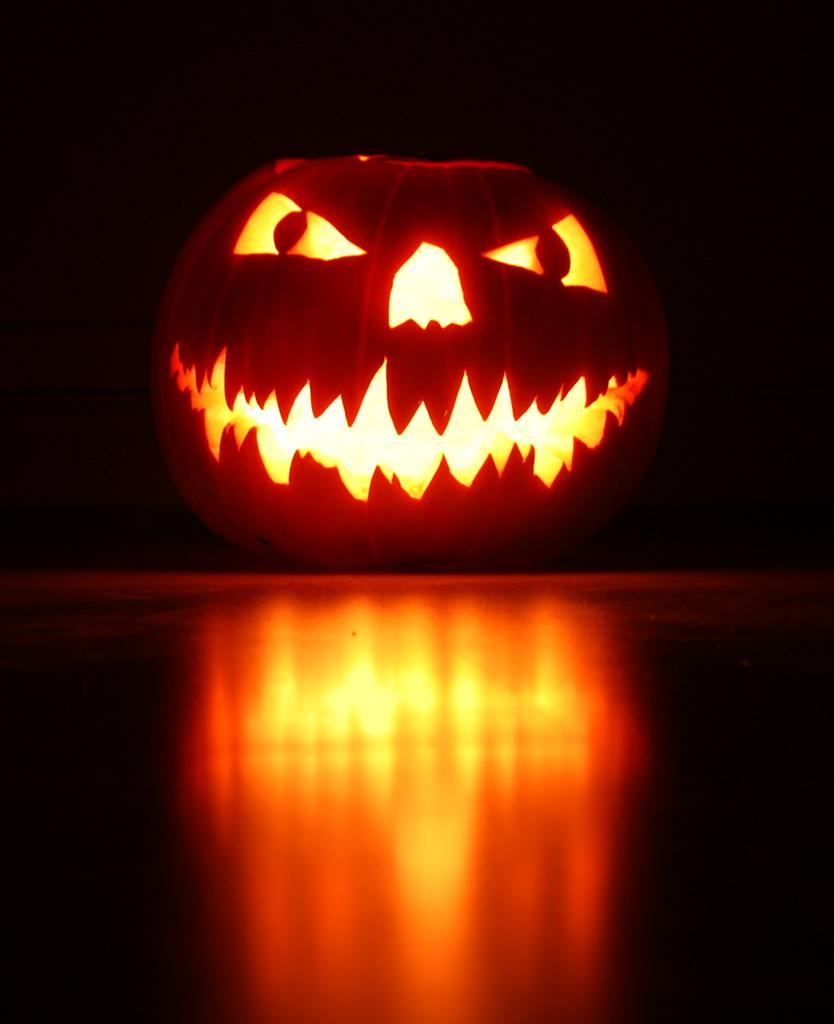What is the main subject in the foreground of the image? There is a carved pumpkin in the foreground of the image. Where is the carved pumpkin located? The carved pumpkin is on the floor. What can be observed about the background of the image? The background of the image is dark. Can you tell me how many cushions are on the carved pumpkin in the image? There are no cushions present on the carved pumpkin in the image. 